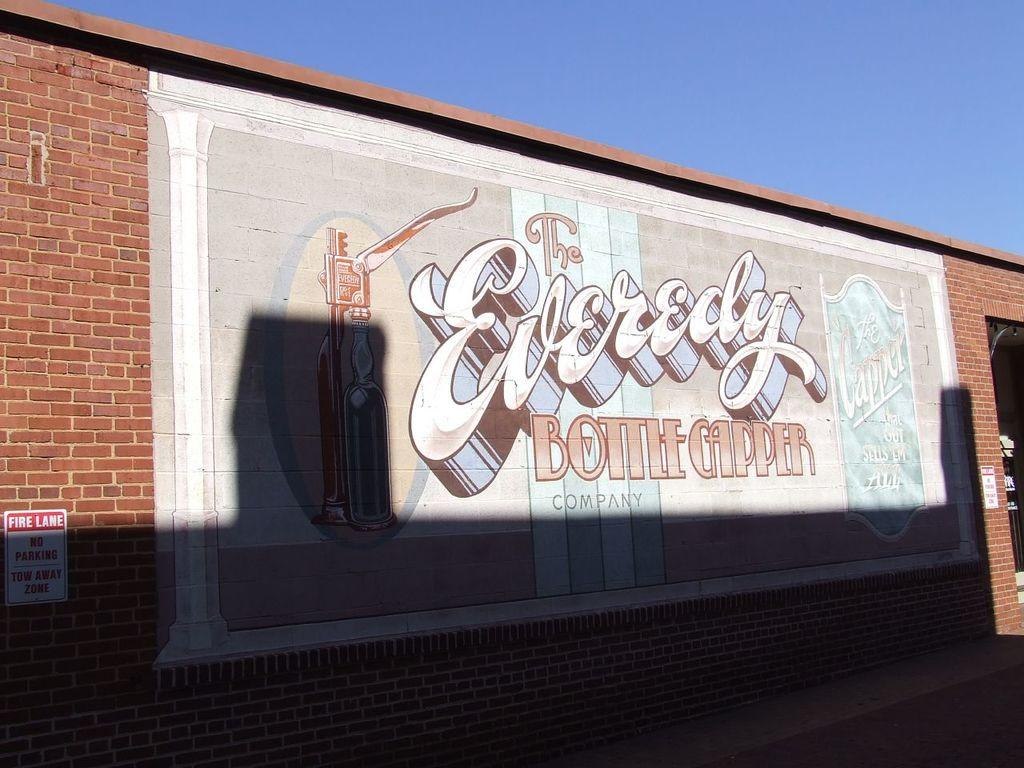What is present on the wall in the image? There is an art piece with text and pictures on the wall. What else can be seen on the wall in the image? There is a board with text in the image. What is visible at the top of the image? The sky is visible at the top of the image. What type of yam is being used as a decorative element in the image? There is no yam present in the image; it features a wall with an art piece and a board with text. How many arches can be seen in the image? There are no arches present in the image. 